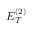<formula> <loc_0><loc_0><loc_500><loc_500>E _ { T } ^ { ( 2 ) }</formula> 